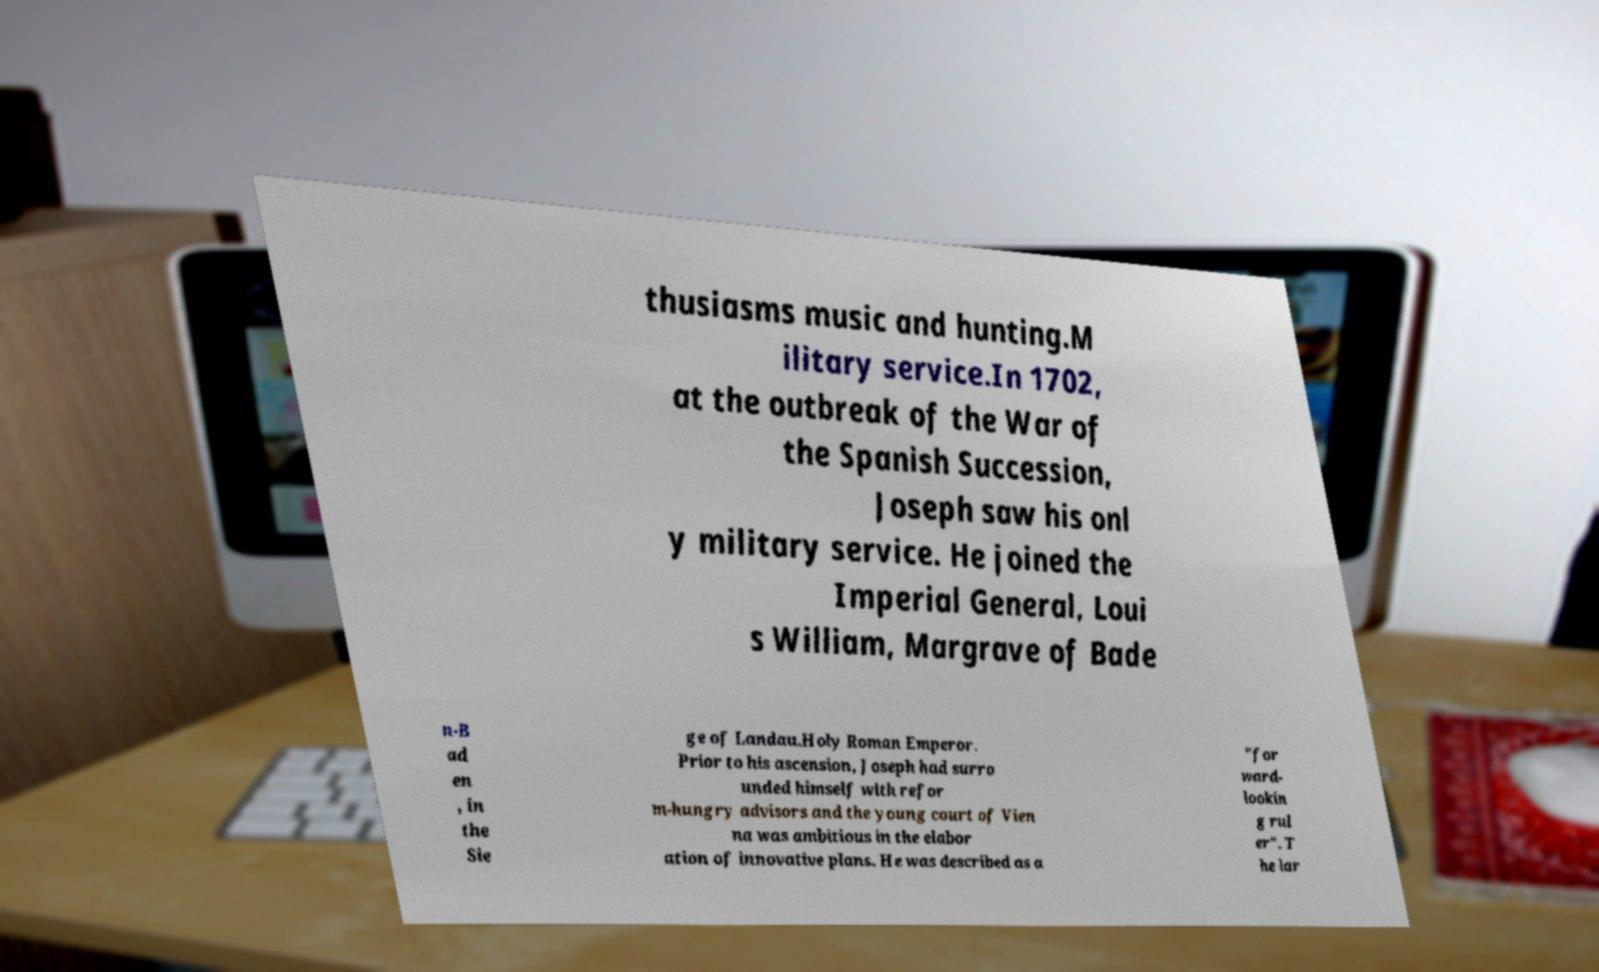What messages or text are displayed in this image? I need them in a readable, typed format. thusiasms music and hunting.M ilitary service.In 1702, at the outbreak of the War of the Spanish Succession, Joseph saw his onl y military service. He joined the Imperial General, Loui s William, Margrave of Bade n-B ad en , in the Sie ge of Landau.Holy Roman Emperor. Prior to his ascension, Joseph had surro unded himself with refor m-hungry advisors and the young court of Vien na was ambitious in the elabor ation of innovative plans. He was described as a "for ward- lookin g rul er". T he lar 